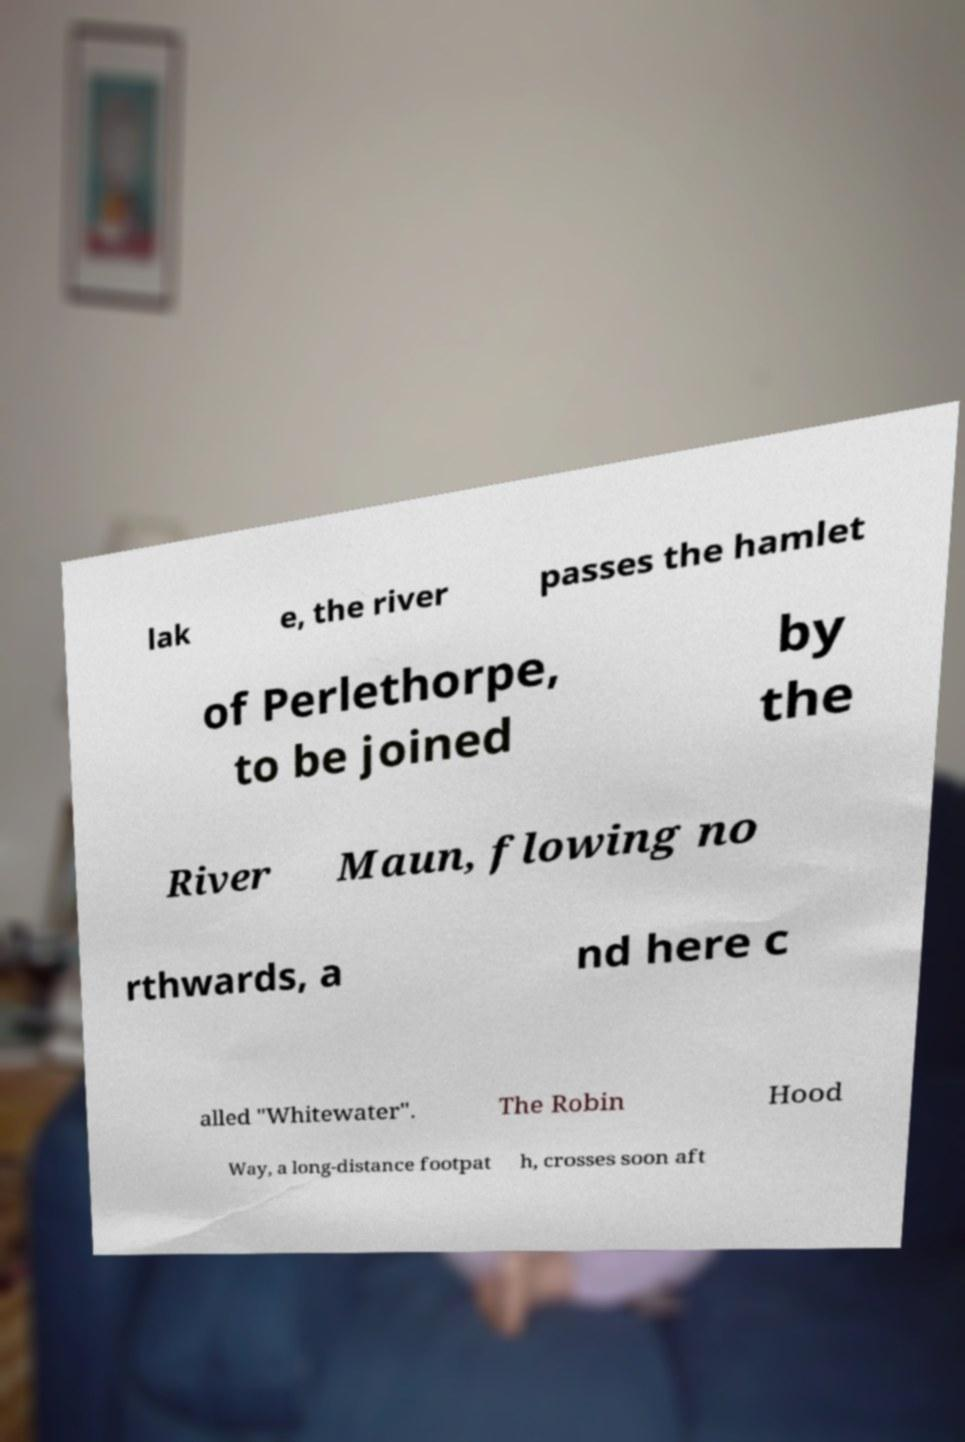There's text embedded in this image that I need extracted. Can you transcribe it verbatim? lak e, the river passes the hamlet of Perlethorpe, to be joined by the River Maun, flowing no rthwards, a nd here c alled "Whitewater". The Robin Hood Way, a long-distance footpat h, crosses soon aft 